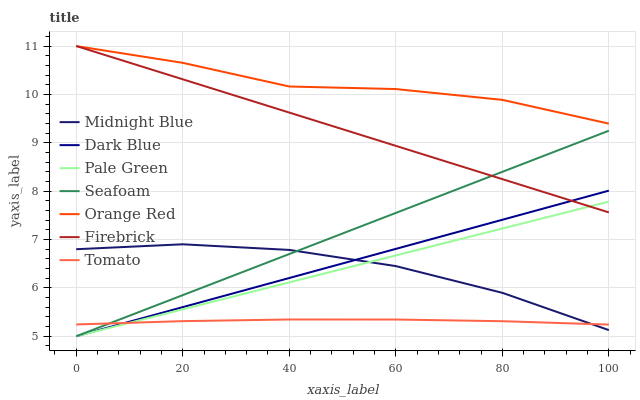Does Tomato have the minimum area under the curve?
Answer yes or no. Yes. Does Orange Red have the maximum area under the curve?
Answer yes or no. Yes. Does Midnight Blue have the minimum area under the curve?
Answer yes or no. No. Does Midnight Blue have the maximum area under the curve?
Answer yes or no. No. Is Dark Blue the smoothest?
Answer yes or no. Yes. Is Orange Red the roughest?
Answer yes or no. Yes. Is Midnight Blue the smoothest?
Answer yes or no. No. Is Midnight Blue the roughest?
Answer yes or no. No. Does Seafoam have the lowest value?
Answer yes or no. Yes. Does Midnight Blue have the lowest value?
Answer yes or no. No. Does Firebrick have the highest value?
Answer yes or no. Yes. Does Midnight Blue have the highest value?
Answer yes or no. No. Is Midnight Blue less than Orange Red?
Answer yes or no. Yes. Is Firebrick greater than Midnight Blue?
Answer yes or no. Yes. Does Dark Blue intersect Tomato?
Answer yes or no. Yes. Is Dark Blue less than Tomato?
Answer yes or no. No. Is Dark Blue greater than Tomato?
Answer yes or no. No. Does Midnight Blue intersect Orange Red?
Answer yes or no. No. 